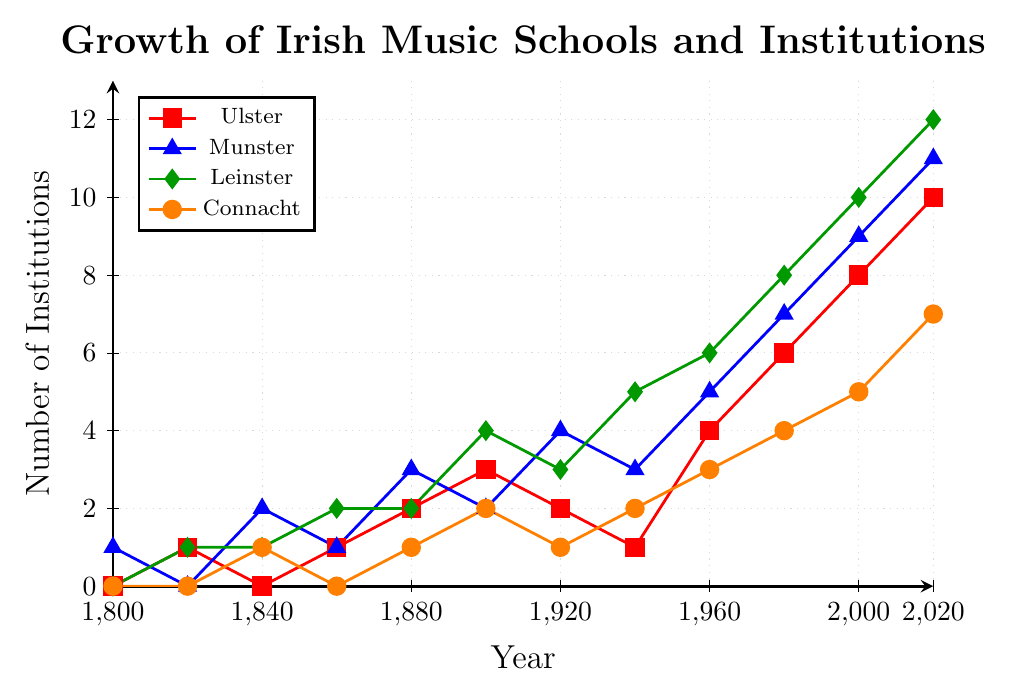What region saw the highest number of new Irish music schools and institutions established in 2020? In 2020, Leinster had the highest number of institutions established, with 12. This conclusion can be reached by examining the endpoint of each line on the plot and identifying the highest point.
Answer: Leinster How many more institutions were established in Munster compared to Connacht in 2000? In 2000, Munster had 9 institutions, while Connacht had 5. The difference is 9 - 5 = 4.
Answer: 4 Which region had the least growth in the number of institutions from 1800 to 2020? From 1800 to 2020, Connacht grew from 0 to 7 institutions, Ulster from 0 to 10, Munster from 1 to 11, and Leinster from 0 to 12. Connacht had the least growth, with an increase of 7 institutions.
Answer: Connacht What is the average number of institutions established across all regions in 1960? In 1960, Ulster had 4, Munster had 5, Leinster had 6, and Connacht had 3 institutions. The average is calculated as (4+5+6+3)/4 = 4.5.
Answer: 4.5 By how much did the number of institutions in Ulster increase from 1800 to 2000? In 1800, Ulster had 0 institutions, and by 2000, it had 8 institutions. The increase is calculated as 8 - 0 = 8.
Answer: 8 Which two regions had the same number of institutions established in 1820? In 1820, both Munster and Connacht had 0 institutions established. This conclusion is drawn by examining the markers on the plot at the year 1820.
Answer: Munster and Connacht During which time interval did Leinster see the most significant growth in institutions? Leinster experienced the most significant growth between 1940 and 1960, where the number of institutions increased from 5 to 6.
Answer: 1940 - 1960 How did the growth pattern in Ulster compare to that in Munster from 1800 to 2020? From 1800 to 2020, the growth pattern in Ulster and Munster both show steady increases. However, Munster started with an initial count of 1 and had more gradual but increasing steps, reaching 11 institutions in 2020, whereas Ulster had a more irregular growth pattern, ultimately reaching 10 institutions in 2020.
Answer: Steady growth for both, with Munster reaching 11 and Ulster 10 in 2020 By how many institutions did the total number of institutions established across all regions grow from 1880 to 1980? In 1880, the total number of institutions was 2 (Ulster) + 3 (Munster) + 2 (Leinster) + 1 (Connacht) = 8. In 1980, it was 6 (Ulster) + 7 (Munster) + 8 (Leinster) + 4 (Connacht) = 25. The growth is 25 - 8 = 17 institutions.
Answer: 17 Which color line represents Leinster, and how has its trajectory changed over time? The green line represents Leinster. Over time, its trajectory has shown a consistent and strong upward trend, starting at 0 in 1800 and reaching 12 in 2020.
Answer: Green, consistent upward trend 